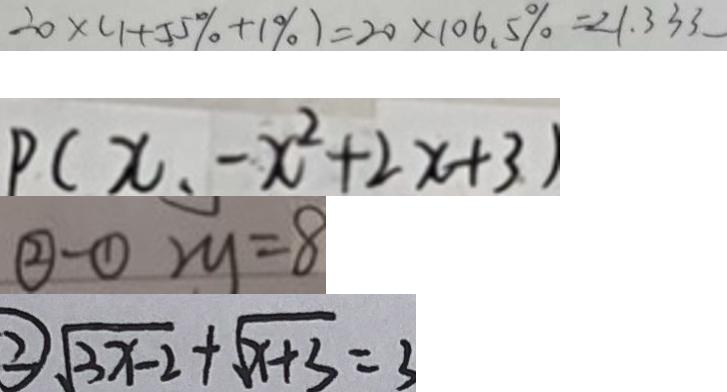Convert formula to latex. <formula><loc_0><loc_0><loc_500><loc_500>2 0 \times ( 1 + 5 5 \% + 1 \% ) = 2 0 \times 1 0 6 . 5 \% = 2 1 . 3 3 3 
 P ( x _ { 1 } - x ^ { 2 } + 2 x + 3 ) 
 \textcircled { 2 } - \textcircled { 1 } 2 y = 8 
 \textcircled { 2 } \sqrt { 3 x - 2 } + \sqrt { x + 3 } = 3</formula> 